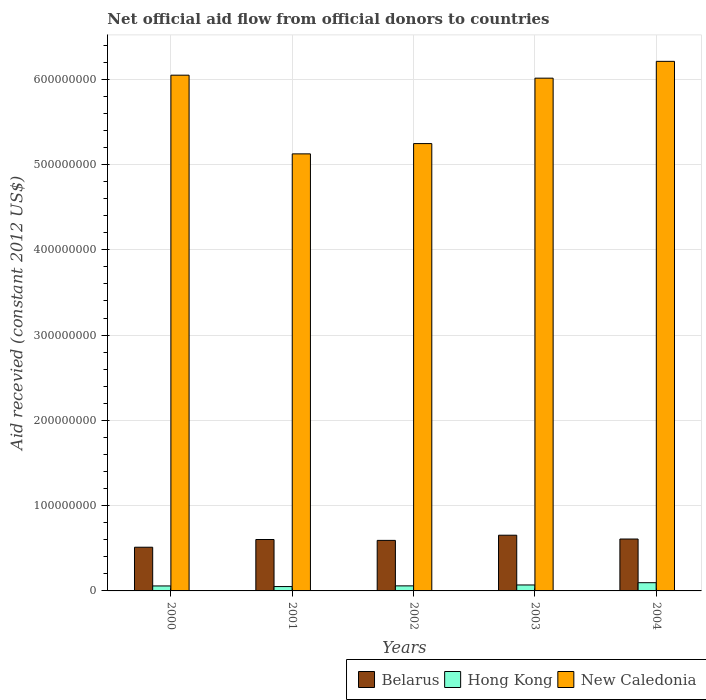Are the number of bars per tick equal to the number of legend labels?
Your response must be concise. Yes. What is the label of the 3rd group of bars from the left?
Give a very brief answer. 2002. What is the total aid received in Belarus in 2000?
Provide a succinct answer. 5.12e+07. Across all years, what is the maximum total aid received in Belarus?
Provide a short and direct response. 6.53e+07. Across all years, what is the minimum total aid received in Hong Kong?
Make the answer very short. 5.12e+06. In which year was the total aid received in New Caledonia maximum?
Offer a very short reply. 2004. In which year was the total aid received in New Caledonia minimum?
Keep it short and to the point. 2001. What is the total total aid received in Hong Kong in the graph?
Provide a short and direct response. 3.35e+07. What is the difference between the total aid received in New Caledonia in 2000 and that in 2002?
Your answer should be compact. 8.02e+07. What is the difference between the total aid received in Belarus in 2001 and the total aid received in Hong Kong in 2004?
Give a very brief answer. 5.06e+07. What is the average total aid received in Hong Kong per year?
Provide a short and direct response. 6.70e+06. In the year 2001, what is the difference between the total aid received in Hong Kong and total aid received in New Caledonia?
Your response must be concise. -5.07e+08. What is the ratio of the total aid received in Belarus in 2002 to that in 2003?
Your answer should be compact. 0.91. Is the total aid received in Hong Kong in 2001 less than that in 2002?
Give a very brief answer. Yes. What is the difference between the highest and the second highest total aid received in Belarus?
Your answer should be compact. 4.47e+06. What is the difference between the highest and the lowest total aid received in Hong Kong?
Provide a succinct answer. 4.53e+06. What does the 2nd bar from the left in 2004 represents?
Give a very brief answer. Hong Kong. What does the 1st bar from the right in 2000 represents?
Offer a terse response. New Caledonia. Is it the case that in every year, the sum of the total aid received in New Caledonia and total aid received in Belarus is greater than the total aid received in Hong Kong?
Give a very brief answer. Yes. What is the difference between two consecutive major ticks on the Y-axis?
Your answer should be compact. 1.00e+08. Are the values on the major ticks of Y-axis written in scientific E-notation?
Your answer should be compact. No. Does the graph contain any zero values?
Offer a very short reply. No. Does the graph contain grids?
Your answer should be very brief. Yes. Where does the legend appear in the graph?
Your answer should be very brief. Bottom right. How many legend labels are there?
Offer a terse response. 3. What is the title of the graph?
Your answer should be compact. Net official aid flow from official donors to countries. What is the label or title of the Y-axis?
Offer a terse response. Aid recevied (constant 2012 US$). What is the Aid recevied (constant 2012 US$) in Belarus in 2000?
Your answer should be very brief. 5.12e+07. What is the Aid recevied (constant 2012 US$) of Hong Kong in 2000?
Your answer should be compact. 5.83e+06. What is the Aid recevied (constant 2012 US$) in New Caledonia in 2000?
Offer a very short reply. 6.05e+08. What is the Aid recevied (constant 2012 US$) of Belarus in 2001?
Ensure brevity in your answer.  6.03e+07. What is the Aid recevied (constant 2012 US$) in Hong Kong in 2001?
Ensure brevity in your answer.  5.12e+06. What is the Aid recevied (constant 2012 US$) in New Caledonia in 2001?
Your response must be concise. 5.13e+08. What is the Aid recevied (constant 2012 US$) of Belarus in 2002?
Offer a very short reply. 5.93e+07. What is the Aid recevied (constant 2012 US$) of Hong Kong in 2002?
Offer a terse response. 5.92e+06. What is the Aid recevied (constant 2012 US$) in New Caledonia in 2002?
Provide a succinct answer. 5.25e+08. What is the Aid recevied (constant 2012 US$) in Belarus in 2003?
Ensure brevity in your answer.  6.53e+07. What is the Aid recevied (constant 2012 US$) in Hong Kong in 2003?
Provide a short and direct response. 6.99e+06. What is the Aid recevied (constant 2012 US$) in New Caledonia in 2003?
Keep it short and to the point. 6.01e+08. What is the Aid recevied (constant 2012 US$) of Belarus in 2004?
Give a very brief answer. 6.09e+07. What is the Aid recevied (constant 2012 US$) in Hong Kong in 2004?
Your answer should be very brief. 9.65e+06. What is the Aid recevied (constant 2012 US$) in New Caledonia in 2004?
Keep it short and to the point. 6.21e+08. Across all years, what is the maximum Aid recevied (constant 2012 US$) of Belarus?
Your response must be concise. 6.53e+07. Across all years, what is the maximum Aid recevied (constant 2012 US$) of Hong Kong?
Give a very brief answer. 9.65e+06. Across all years, what is the maximum Aid recevied (constant 2012 US$) in New Caledonia?
Ensure brevity in your answer.  6.21e+08. Across all years, what is the minimum Aid recevied (constant 2012 US$) of Belarus?
Your answer should be very brief. 5.12e+07. Across all years, what is the minimum Aid recevied (constant 2012 US$) of Hong Kong?
Give a very brief answer. 5.12e+06. Across all years, what is the minimum Aid recevied (constant 2012 US$) of New Caledonia?
Keep it short and to the point. 5.13e+08. What is the total Aid recevied (constant 2012 US$) of Belarus in the graph?
Offer a terse response. 2.97e+08. What is the total Aid recevied (constant 2012 US$) in Hong Kong in the graph?
Provide a succinct answer. 3.35e+07. What is the total Aid recevied (constant 2012 US$) in New Caledonia in the graph?
Offer a terse response. 2.86e+09. What is the difference between the Aid recevied (constant 2012 US$) in Belarus in 2000 and that in 2001?
Provide a short and direct response. -9.04e+06. What is the difference between the Aid recevied (constant 2012 US$) of Hong Kong in 2000 and that in 2001?
Give a very brief answer. 7.10e+05. What is the difference between the Aid recevied (constant 2012 US$) in New Caledonia in 2000 and that in 2001?
Offer a very short reply. 9.23e+07. What is the difference between the Aid recevied (constant 2012 US$) in Belarus in 2000 and that in 2002?
Your answer should be compact. -8.02e+06. What is the difference between the Aid recevied (constant 2012 US$) in Hong Kong in 2000 and that in 2002?
Your answer should be compact. -9.00e+04. What is the difference between the Aid recevied (constant 2012 US$) in New Caledonia in 2000 and that in 2002?
Your answer should be very brief. 8.02e+07. What is the difference between the Aid recevied (constant 2012 US$) of Belarus in 2000 and that in 2003?
Provide a short and direct response. -1.41e+07. What is the difference between the Aid recevied (constant 2012 US$) in Hong Kong in 2000 and that in 2003?
Your answer should be very brief. -1.16e+06. What is the difference between the Aid recevied (constant 2012 US$) of New Caledonia in 2000 and that in 2003?
Your answer should be compact. 3.50e+06. What is the difference between the Aid recevied (constant 2012 US$) in Belarus in 2000 and that in 2004?
Your answer should be compact. -9.61e+06. What is the difference between the Aid recevied (constant 2012 US$) of Hong Kong in 2000 and that in 2004?
Ensure brevity in your answer.  -3.82e+06. What is the difference between the Aid recevied (constant 2012 US$) of New Caledonia in 2000 and that in 2004?
Provide a short and direct response. -1.62e+07. What is the difference between the Aid recevied (constant 2012 US$) in Belarus in 2001 and that in 2002?
Keep it short and to the point. 1.02e+06. What is the difference between the Aid recevied (constant 2012 US$) in Hong Kong in 2001 and that in 2002?
Your answer should be compact. -8.00e+05. What is the difference between the Aid recevied (constant 2012 US$) of New Caledonia in 2001 and that in 2002?
Your response must be concise. -1.21e+07. What is the difference between the Aid recevied (constant 2012 US$) in Belarus in 2001 and that in 2003?
Offer a very short reply. -5.04e+06. What is the difference between the Aid recevied (constant 2012 US$) in Hong Kong in 2001 and that in 2003?
Provide a short and direct response. -1.87e+06. What is the difference between the Aid recevied (constant 2012 US$) of New Caledonia in 2001 and that in 2003?
Offer a terse response. -8.88e+07. What is the difference between the Aid recevied (constant 2012 US$) of Belarus in 2001 and that in 2004?
Make the answer very short. -5.70e+05. What is the difference between the Aid recevied (constant 2012 US$) in Hong Kong in 2001 and that in 2004?
Offer a terse response. -4.53e+06. What is the difference between the Aid recevied (constant 2012 US$) of New Caledonia in 2001 and that in 2004?
Provide a succinct answer. -1.08e+08. What is the difference between the Aid recevied (constant 2012 US$) in Belarus in 2002 and that in 2003?
Give a very brief answer. -6.06e+06. What is the difference between the Aid recevied (constant 2012 US$) of Hong Kong in 2002 and that in 2003?
Your answer should be very brief. -1.07e+06. What is the difference between the Aid recevied (constant 2012 US$) in New Caledonia in 2002 and that in 2003?
Keep it short and to the point. -7.67e+07. What is the difference between the Aid recevied (constant 2012 US$) of Belarus in 2002 and that in 2004?
Give a very brief answer. -1.59e+06. What is the difference between the Aid recevied (constant 2012 US$) of Hong Kong in 2002 and that in 2004?
Ensure brevity in your answer.  -3.73e+06. What is the difference between the Aid recevied (constant 2012 US$) in New Caledonia in 2002 and that in 2004?
Make the answer very short. -9.64e+07. What is the difference between the Aid recevied (constant 2012 US$) in Belarus in 2003 and that in 2004?
Ensure brevity in your answer.  4.47e+06. What is the difference between the Aid recevied (constant 2012 US$) in Hong Kong in 2003 and that in 2004?
Keep it short and to the point. -2.66e+06. What is the difference between the Aid recevied (constant 2012 US$) of New Caledonia in 2003 and that in 2004?
Keep it short and to the point. -1.97e+07. What is the difference between the Aid recevied (constant 2012 US$) of Belarus in 2000 and the Aid recevied (constant 2012 US$) of Hong Kong in 2001?
Give a very brief answer. 4.61e+07. What is the difference between the Aid recevied (constant 2012 US$) in Belarus in 2000 and the Aid recevied (constant 2012 US$) in New Caledonia in 2001?
Offer a very short reply. -4.61e+08. What is the difference between the Aid recevied (constant 2012 US$) of Hong Kong in 2000 and the Aid recevied (constant 2012 US$) of New Caledonia in 2001?
Offer a very short reply. -5.07e+08. What is the difference between the Aid recevied (constant 2012 US$) in Belarus in 2000 and the Aid recevied (constant 2012 US$) in Hong Kong in 2002?
Provide a succinct answer. 4.53e+07. What is the difference between the Aid recevied (constant 2012 US$) of Belarus in 2000 and the Aid recevied (constant 2012 US$) of New Caledonia in 2002?
Your response must be concise. -4.73e+08. What is the difference between the Aid recevied (constant 2012 US$) of Hong Kong in 2000 and the Aid recevied (constant 2012 US$) of New Caledonia in 2002?
Keep it short and to the point. -5.19e+08. What is the difference between the Aid recevied (constant 2012 US$) in Belarus in 2000 and the Aid recevied (constant 2012 US$) in Hong Kong in 2003?
Your answer should be very brief. 4.43e+07. What is the difference between the Aid recevied (constant 2012 US$) in Belarus in 2000 and the Aid recevied (constant 2012 US$) in New Caledonia in 2003?
Make the answer very short. -5.50e+08. What is the difference between the Aid recevied (constant 2012 US$) of Hong Kong in 2000 and the Aid recevied (constant 2012 US$) of New Caledonia in 2003?
Your answer should be very brief. -5.95e+08. What is the difference between the Aid recevied (constant 2012 US$) in Belarus in 2000 and the Aid recevied (constant 2012 US$) in Hong Kong in 2004?
Give a very brief answer. 4.16e+07. What is the difference between the Aid recevied (constant 2012 US$) of Belarus in 2000 and the Aid recevied (constant 2012 US$) of New Caledonia in 2004?
Make the answer very short. -5.70e+08. What is the difference between the Aid recevied (constant 2012 US$) in Hong Kong in 2000 and the Aid recevied (constant 2012 US$) in New Caledonia in 2004?
Offer a very short reply. -6.15e+08. What is the difference between the Aid recevied (constant 2012 US$) in Belarus in 2001 and the Aid recevied (constant 2012 US$) in Hong Kong in 2002?
Your response must be concise. 5.44e+07. What is the difference between the Aid recevied (constant 2012 US$) of Belarus in 2001 and the Aid recevied (constant 2012 US$) of New Caledonia in 2002?
Give a very brief answer. -4.64e+08. What is the difference between the Aid recevied (constant 2012 US$) in Hong Kong in 2001 and the Aid recevied (constant 2012 US$) in New Caledonia in 2002?
Give a very brief answer. -5.19e+08. What is the difference between the Aid recevied (constant 2012 US$) in Belarus in 2001 and the Aid recevied (constant 2012 US$) in Hong Kong in 2003?
Give a very brief answer. 5.33e+07. What is the difference between the Aid recevied (constant 2012 US$) of Belarus in 2001 and the Aid recevied (constant 2012 US$) of New Caledonia in 2003?
Ensure brevity in your answer.  -5.41e+08. What is the difference between the Aid recevied (constant 2012 US$) in Hong Kong in 2001 and the Aid recevied (constant 2012 US$) in New Caledonia in 2003?
Your response must be concise. -5.96e+08. What is the difference between the Aid recevied (constant 2012 US$) in Belarus in 2001 and the Aid recevied (constant 2012 US$) in Hong Kong in 2004?
Make the answer very short. 5.06e+07. What is the difference between the Aid recevied (constant 2012 US$) in Belarus in 2001 and the Aid recevied (constant 2012 US$) in New Caledonia in 2004?
Offer a terse response. -5.61e+08. What is the difference between the Aid recevied (constant 2012 US$) of Hong Kong in 2001 and the Aid recevied (constant 2012 US$) of New Caledonia in 2004?
Ensure brevity in your answer.  -6.16e+08. What is the difference between the Aid recevied (constant 2012 US$) in Belarus in 2002 and the Aid recevied (constant 2012 US$) in Hong Kong in 2003?
Give a very brief answer. 5.23e+07. What is the difference between the Aid recevied (constant 2012 US$) of Belarus in 2002 and the Aid recevied (constant 2012 US$) of New Caledonia in 2003?
Offer a terse response. -5.42e+08. What is the difference between the Aid recevied (constant 2012 US$) of Hong Kong in 2002 and the Aid recevied (constant 2012 US$) of New Caledonia in 2003?
Your answer should be compact. -5.95e+08. What is the difference between the Aid recevied (constant 2012 US$) of Belarus in 2002 and the Aid recevied (constant 2012 US$) of Hong Kong in 2004?
Your answer should be very brief. 4.96e+07. What is the difference between the Aid recevied (constant 2012 US$) in Belarus in 2002 and the Aid recevied (constant 2012 US$) in New Caledonia in 2004?
Offer a very short reply. -5.62e+08. What is the difference between the Aid recevied (constant 2012 US$) of Hong Kong in 2002 and the Aid recevied (constant 2012 US$) of New Caledonia in 2004?
Your response must be concise. -6.15e+08. What is the difference between the Aid recevied (constant 2012 US$) of Belarus in 2003 and the Aid recevied (constant 2012 US$) of Hong Kong in 2004?
Your answer should be very brief. 5.57e+07. What is the difference between the Aid recevied (constant 2012 US$) of Belarus in 2003 and the Aid recevied (constant 2012 US$) of New Caledonia in 2004?
Keep it short and to the point. -5.56e+08. What is the difference between the Aid recevied (constant 2012 US$) in Hong Kong in 2003 and the Aid recevied (constant 2012 US$) in New Caledonia in 2004?
Your response must be concise. -6.14e+08. What is the average Aid recevied (constant 2012 US$) in Belarus per year?
Provide a succinct answer. 5.94e+07. What is the average Aid recevied (constant 2012 US$) of Hong Kong per year?
Offer a very short reply. 6.70e+06. What is the average Aid recevied (constant 2012 US$) in New Caledonia per year?
Provide a succinct answer. 5.73e+08. In the year 2000, what is the difference between the Aid recevied (constant 2012 US$) of Belarus and Aid recevied (constant 2012 US$) of Hong Kong?
Provide a succinct answer. 4.54e+07. In the year 2000, what is the difference between the Aid recevied (constant 2012 US$) in Belarus and Aid recevied (constant 2012 US$) in New Caledonia?
Provide a succinct answer. -5.54e+08. In the year 2000, what is the difference between the Aid recevied (constant 2012 US$) in Hong Kong and Aid recevied (constant 2012 US$) in New Caledonia?
Give a very brief answer. -5.99e+08. In the year 2001, what is the difference between the Aid recevied (constant 2012 US$) of Belarus and Aid recevied (constant 2012 US$) of Hong Kong?
Provide a short and direct response. 5.52e+07. In the year 2001, what is the difference between the Aid recevied (constant 2012 US$) in Belarus and Aid recevied (constant 2012 US$) in New Caledonia?
Make the answer very short. -4.52e+08. In the year 2001, what is the difference between the Aid recevied (constant 2012 US$) of Hong Kong and Aid recevied (constant 2012 US$) of New Caledonia?
Provide a short and direct response. -5.07e+08. In the year 2002, what is the difference between the Aid recevied (constant 2012 US$) of Belarus and Aid recevied (constant 2012 US$) of Hong Kong?
Ensure brevity in your answer.  5.34e+07. In the year 2002, what is the difference between the Aid recevied (constant 2012 US$) in Belarus and Aid recevied (constant 2012 US$) in New Caledonia?
Your answer should be compact. -4.65e+08. In the year 2002, what is the difference between the Aid recevied (constant 2012 US$) in Hong Kong and Aid recevied (constant 2012 US$) in New Caledonia?
Provide a succinct answer. -5.19e+08. In the year 2003, what is the difference between the Aid recevied (constant 2012 US$) in Belarus and Aid recevied (constant 2012 US$) in Hong Kong?
Provide a short and direct response. 5.83e+07. In the year 2003, what is the difference between the Aid recevied (constant 2012 US$) of Belarus and Aid recevied (constant 2012 US$) of New Caledonia?
Ensure brevity in your answer.  -5.36e+08. In the year 2003, what is the difference between the Aid recevied (constant 2012 US$) of Hong Kong and Aid recevied (constant 2012 US$) of New Caledonia?
Your answer should be very brief. -5.94e+08. In the year 2004, what is the difference between the Aid recevied (constant 2012 US$) of Belarus and Aid recevied (constant 2012 US$) of Hong Kong?
Give a very brief answer. 5.12e+07. In the year 2004, what is the difference between the Aid recevied (constant 2012 US$) in Belarus and Aid recevied (constant 2012 US$) in New Caledonia?
Ensure brevity in your answer.  -5.60e+08. In the year 2004, what is the difference between the Aid recevied (constant 2012 US$) of Hong Kong and Aid recevied (constant 2012 US$) of New Caledonia?
Offer a terse response. -6.11e+08. What is the ratio of the Aid recevied (constant 2012 US$) of Belarus in 2000 to that in 2001?
Provide a short and direct response. 0.85. What is the ratio of the Aid recevied (constant 2012 US$) of Hong Kong in 2000 to that in 2001?
Your answer should be very brief. 1.14. What is the ratio of the Aid recevied (constant 2012 US$) in New Caledonia in 2000 to that in 2001?
Give a very brief answer. 1.18. What is the ratio of the Aid recevied (constant 2012 US$) of Belarus in 2000 to that in 2002?
Offer a very short reply. 0.86. What is the ratio of the Aid recevied (constant 2012 US$) in Hong Kong in 2000 to that in 2002?
Provide a short and direct response. 0.98. What is the ratio of the Aid recevied (constant 2012 US$) of New Caledonia in 2000 to that in 2002?
Your answer should be very brief. 1.15. What is the ratio of the Aid recevied (constant 2012 US$) in Belarus in 2000 to that in 2003?
Your response must be concise. 0.78. What is the ratio of the Aid recevied (constant 2012 US$) in Hong Kong in 2000 to that in 2003?
Ensure brevity in your answer.  0.83. What is the ratio of the Aid recevied (constant 2012 US$) in New Caledonia in 2000 to that in 2003?
Your answer should be very brief. 1.01. What is the ratio of the Aid recevied (constant 2012 US$) of Belarus in 2000 to that in 2004?
Provide a short and direct response. 0.84. What is the ratio of the Aid recevied (constant 2012 US$) of Hong Kong in 2000 to that in 2004?
Your answer should be compact. 0.6. What is the ratio of the Aid recevied (constant 2012 US$) of New Caledonia in 2000 to that in 2004?
Offer a terse response. 0.97. What is the ratio of the Aid recevied (constant 2012 US$) of Belarus in 2001 to that in 2002?
Offer a terse response. 1.02. What is the ratio of the Aid recevied (constant 2012 US$) of Hong Kong in 2001 to that in 2002?
Offer a terse response. 0.86. What is the ratio of the Aid recevied (constant 2012 US$) of New Caledonia in 2001 to that in 2002?
Provide a short and direct response. 0.98. What is the ratio of the Aid recevied (constant 2012 US$) of Belarus in 2001 to that in 2003?
Your response must be concise. 0.92. What is the ratio of the Aid recevied (constant 2012 US$) in Hong Kong in 2001 to that in 2003?
Offer a terse response. 0.73. What is the ratio of the Aid recevied (constant 2012 US$) of New Caledonia in 2001 to that in 2003?
Your response must be concise. 0.85. What is the ratio of the Aid recevied (constant 2012 US$) of Belarus in 2001 to that in 2004?
Provide a short and direct response. 0.99. What is the ratio of the Aid recevied (constant 2012 US$) of Hong Kong in 2001 to that in 2004?
Your response must be concise. 0.53. What is the ratio of the Aid recevied (constant 2012 US$) in New Caledonia in 2001 to that in 2004?
Keep it short and to the point. 0.83. What is the ratio of the Aid recevied (constant 2012 US$) of Belarus in 2002 to that in 2003?
Your answer should be very brief. 0.91. What is the ratio of the Aid recevied (constant 2012 US$) of Hong Kong in 2002 to that in 2003?
Make the answer very short. 0.85. What is the ratio of the Aid recevied (constant 2012 US$) in New Caledonia in 2002 to that in 2003?
Your answer should be very brief. 0.87. What is the ratio of the Aid recevied (constant 2012 US$) in Belarus in 2002 to that in 2004?
Offer a very short reply. 0.97. What is the ratio of the Aid recevied (constant 2012 US$) of Hong Kong in 2002 to that in 2004?
Give a very brief answer. 0.61. What is the ratio of the Aid recevied (constant 2012 US$) in New Caledonia in 2002 to that in 2004?
Offer a terse response. 0.84. What is the ratio of the Aid recevied (constant 2012 US$) of Belarus in 2003 to that in 2004?
Provide a short and direct response. 1.07. What is the ratio of the Aid recevied (constant 2012 US$) of Hong Kong in 2003 to that in 2004?
Provide a succinct answer. 0.72. What is the ratio of the Aid recevied (constant 2012 US$) of New Caledonia in 2003 to that in 2004?
Ensure brevity in your answer.  0.97. What is the difference between the highest and the second highest Aid recevied (constant 2012 US$) in Belarus?
Your response must be concise. 4.47e+06. What is the difference between the highest and the second highest Aid recevied (constant 2012 US$) of Hong Kong?
Your response must be concise. 2.66e+06. What is the difference between the highest and the second highest Aid recevied (constant 2012 US$) of New Caledonia?
Offer a very short reply. 1.62e+07. What is the difference between the highest and the lowest Aid recevied (constant 2012 US$) in Belarus?
Give a very brief answer. 1.41e+07. What is the difference between the highest and the lowest Aid recevied (constant 2012 US$) of Hong Kong?
Offer a terse response. 4.53e+06. What is the difference between the highest and the lowest Aid recevied (constant 2012 US$) of New Caledonia?
Ensure brevity in your answer.  1.08e+08. 